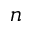Convert formula to latex. <formula><loc_0><loc_0><loc_500><loc_500>n</formula> 